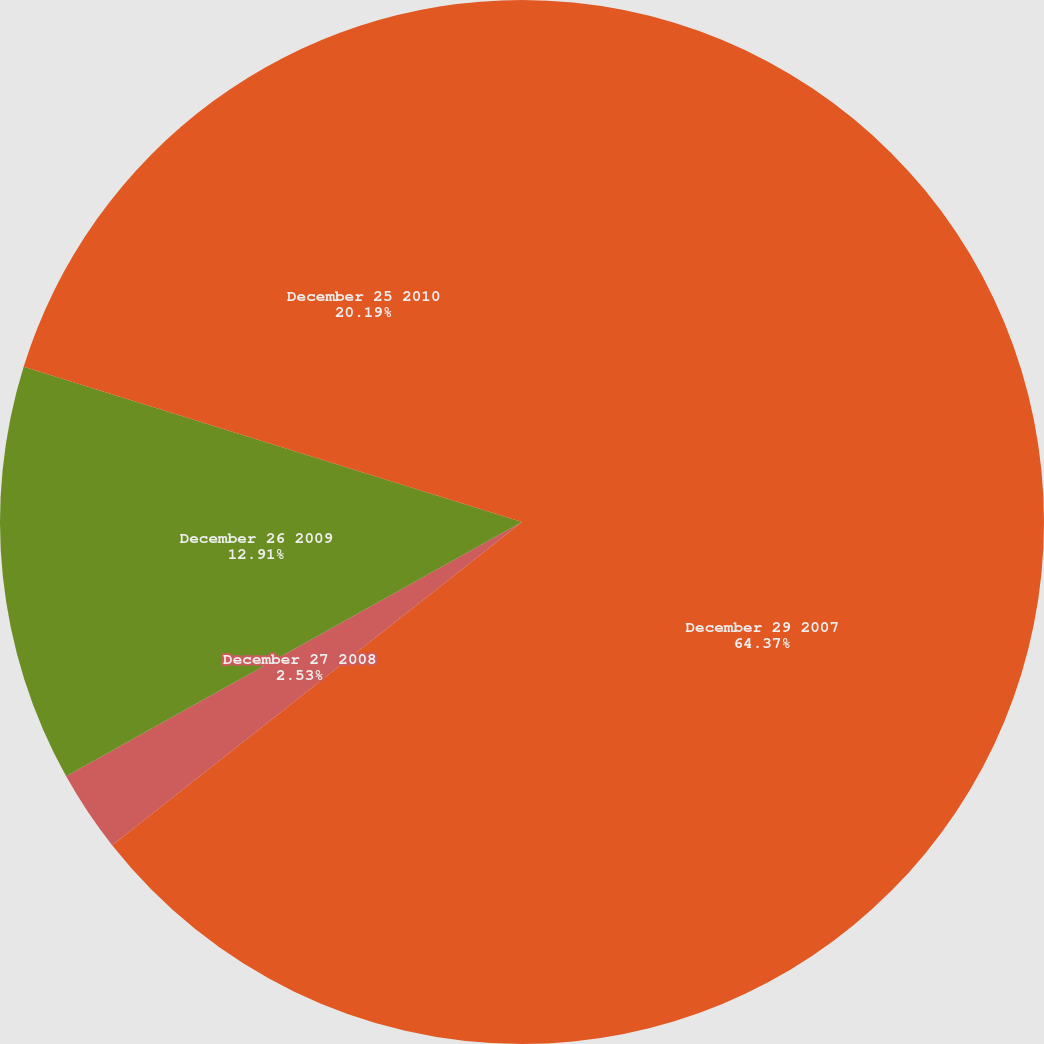<chart> <loc_0><loc_0><loc_500><loc_500><pie_chart><fcel>December 29 2007<fcel>December 27 2008<fcel>December 26 2009<fcel>December 25 2010<nl><fcel>64.37%<fcel>2.53%<fcel>12.91%<fcel>20.19%<nl></chart> 